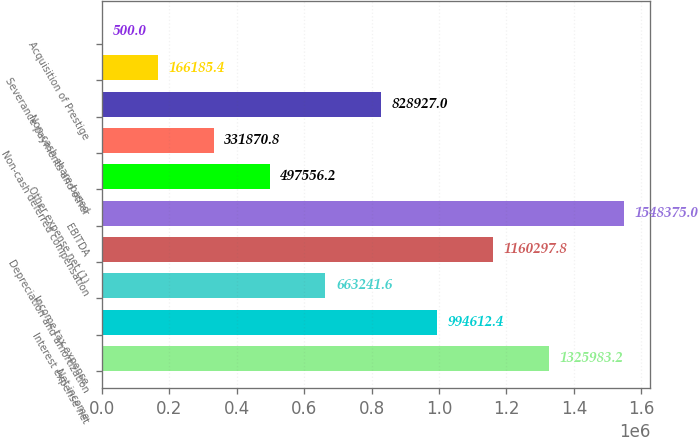Convert chart to OTSL. <chart><loc_0><loc_0><loc_500><loc_500><bar_chart><fcel>Net income<fcel>Interest expense net<fcel>Income tax expense<fcel>Depreciation and amortization<fcel>EBITDA<fcel>Other expense net (1)<fcel>Non-cash deferred compensation<fcel>Non-cash share-based<fcel>Severance payments and other<fcel>Acquisition of Prestige<nl><fcel>1.32598e+06<fcel>994612<fcel>663242<fcel>1.1603e+06<fcel>1.54838e+06<fcel>497556<fcel>331871<fcel>828927<fcel>166185<fcel>500<nl></chart> 